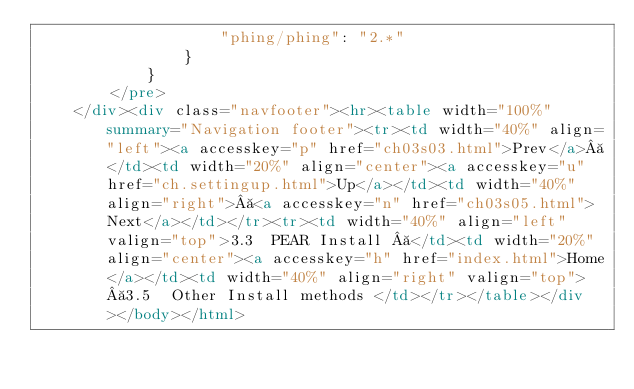Convert code to text. <code><loc_0><loc_0><loc_500><loc_500><_HTML_>                    "phing/phing": "2.*"
                }
            }
        </pre>
    </div><div class="navfooter"><hr><table width="100%" summary="Navigation footer"><tr><td width="40%" align="left"><a accesskey="p" href="ch03s03.html">Prev</a> </td><td width="20%" align="center"><a accesskey="u" href="ch.settingup.html">Up</a></td><td width="40%" align="right"> <a accesskey="n" href="ch03s05.html">Next</a></td></tr><tr><td width="40%" align="left" valign="top">3.3  PEAR Install  </td><td width="20%" align="center"><a accesskey="h" href="index.html">Home</a></td><td width="40%" align="right" valign="top"> 3.5  Other Install methods </td></tr></table></div></body></html>
</code> 